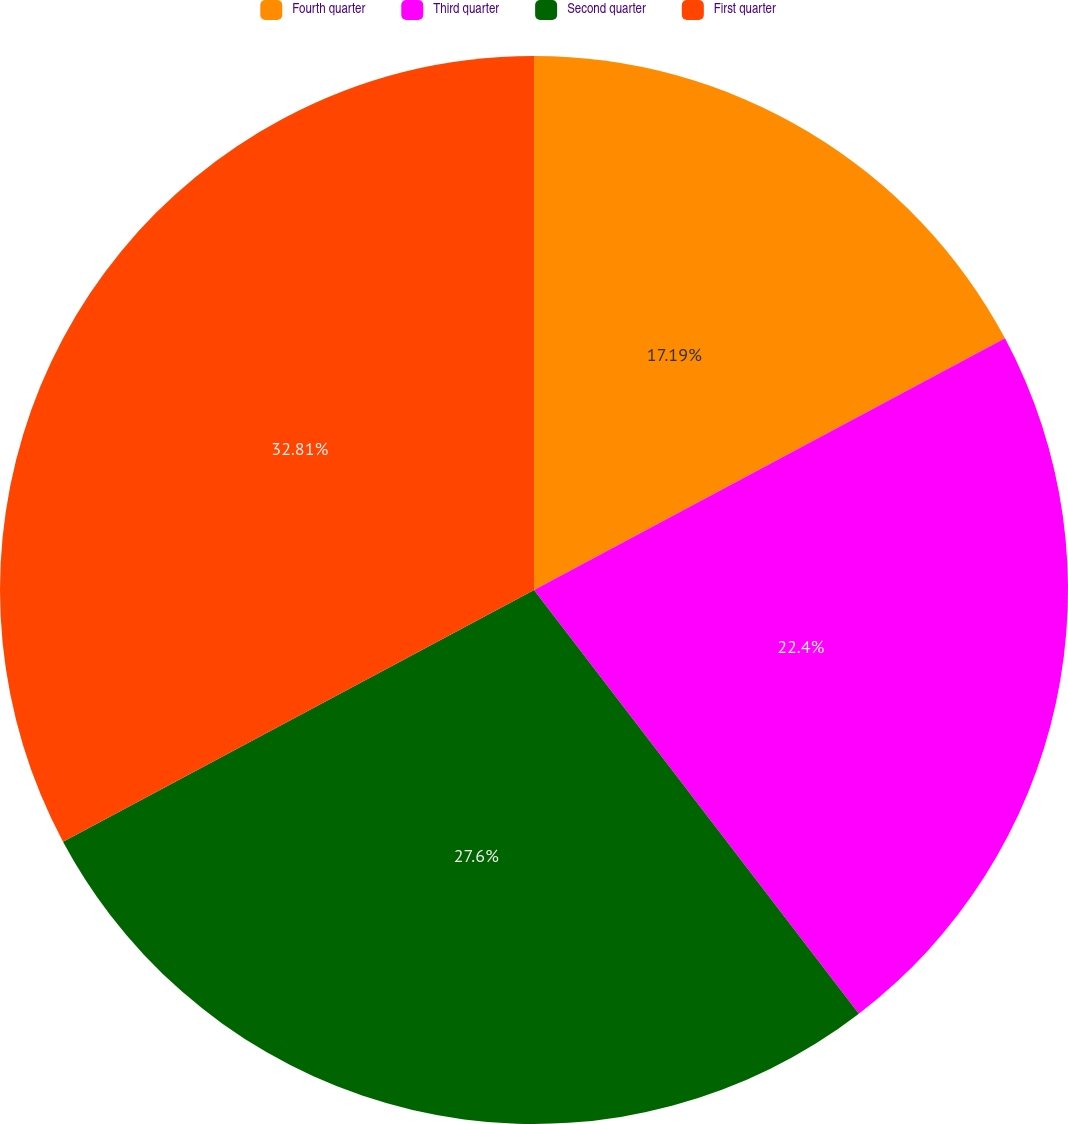Convert chart to OTSL. <chart><loc_0><loc_0><loc_500><loc_500><pie_chart><fcel>Fourth quarter<fcel>Third quarter<fcel>Second quarter<fcel>First quarter<nl><fcel>17.19%<fcel>22.4%<fcel>27.6%<fcel>32.81%<nl></chart> 